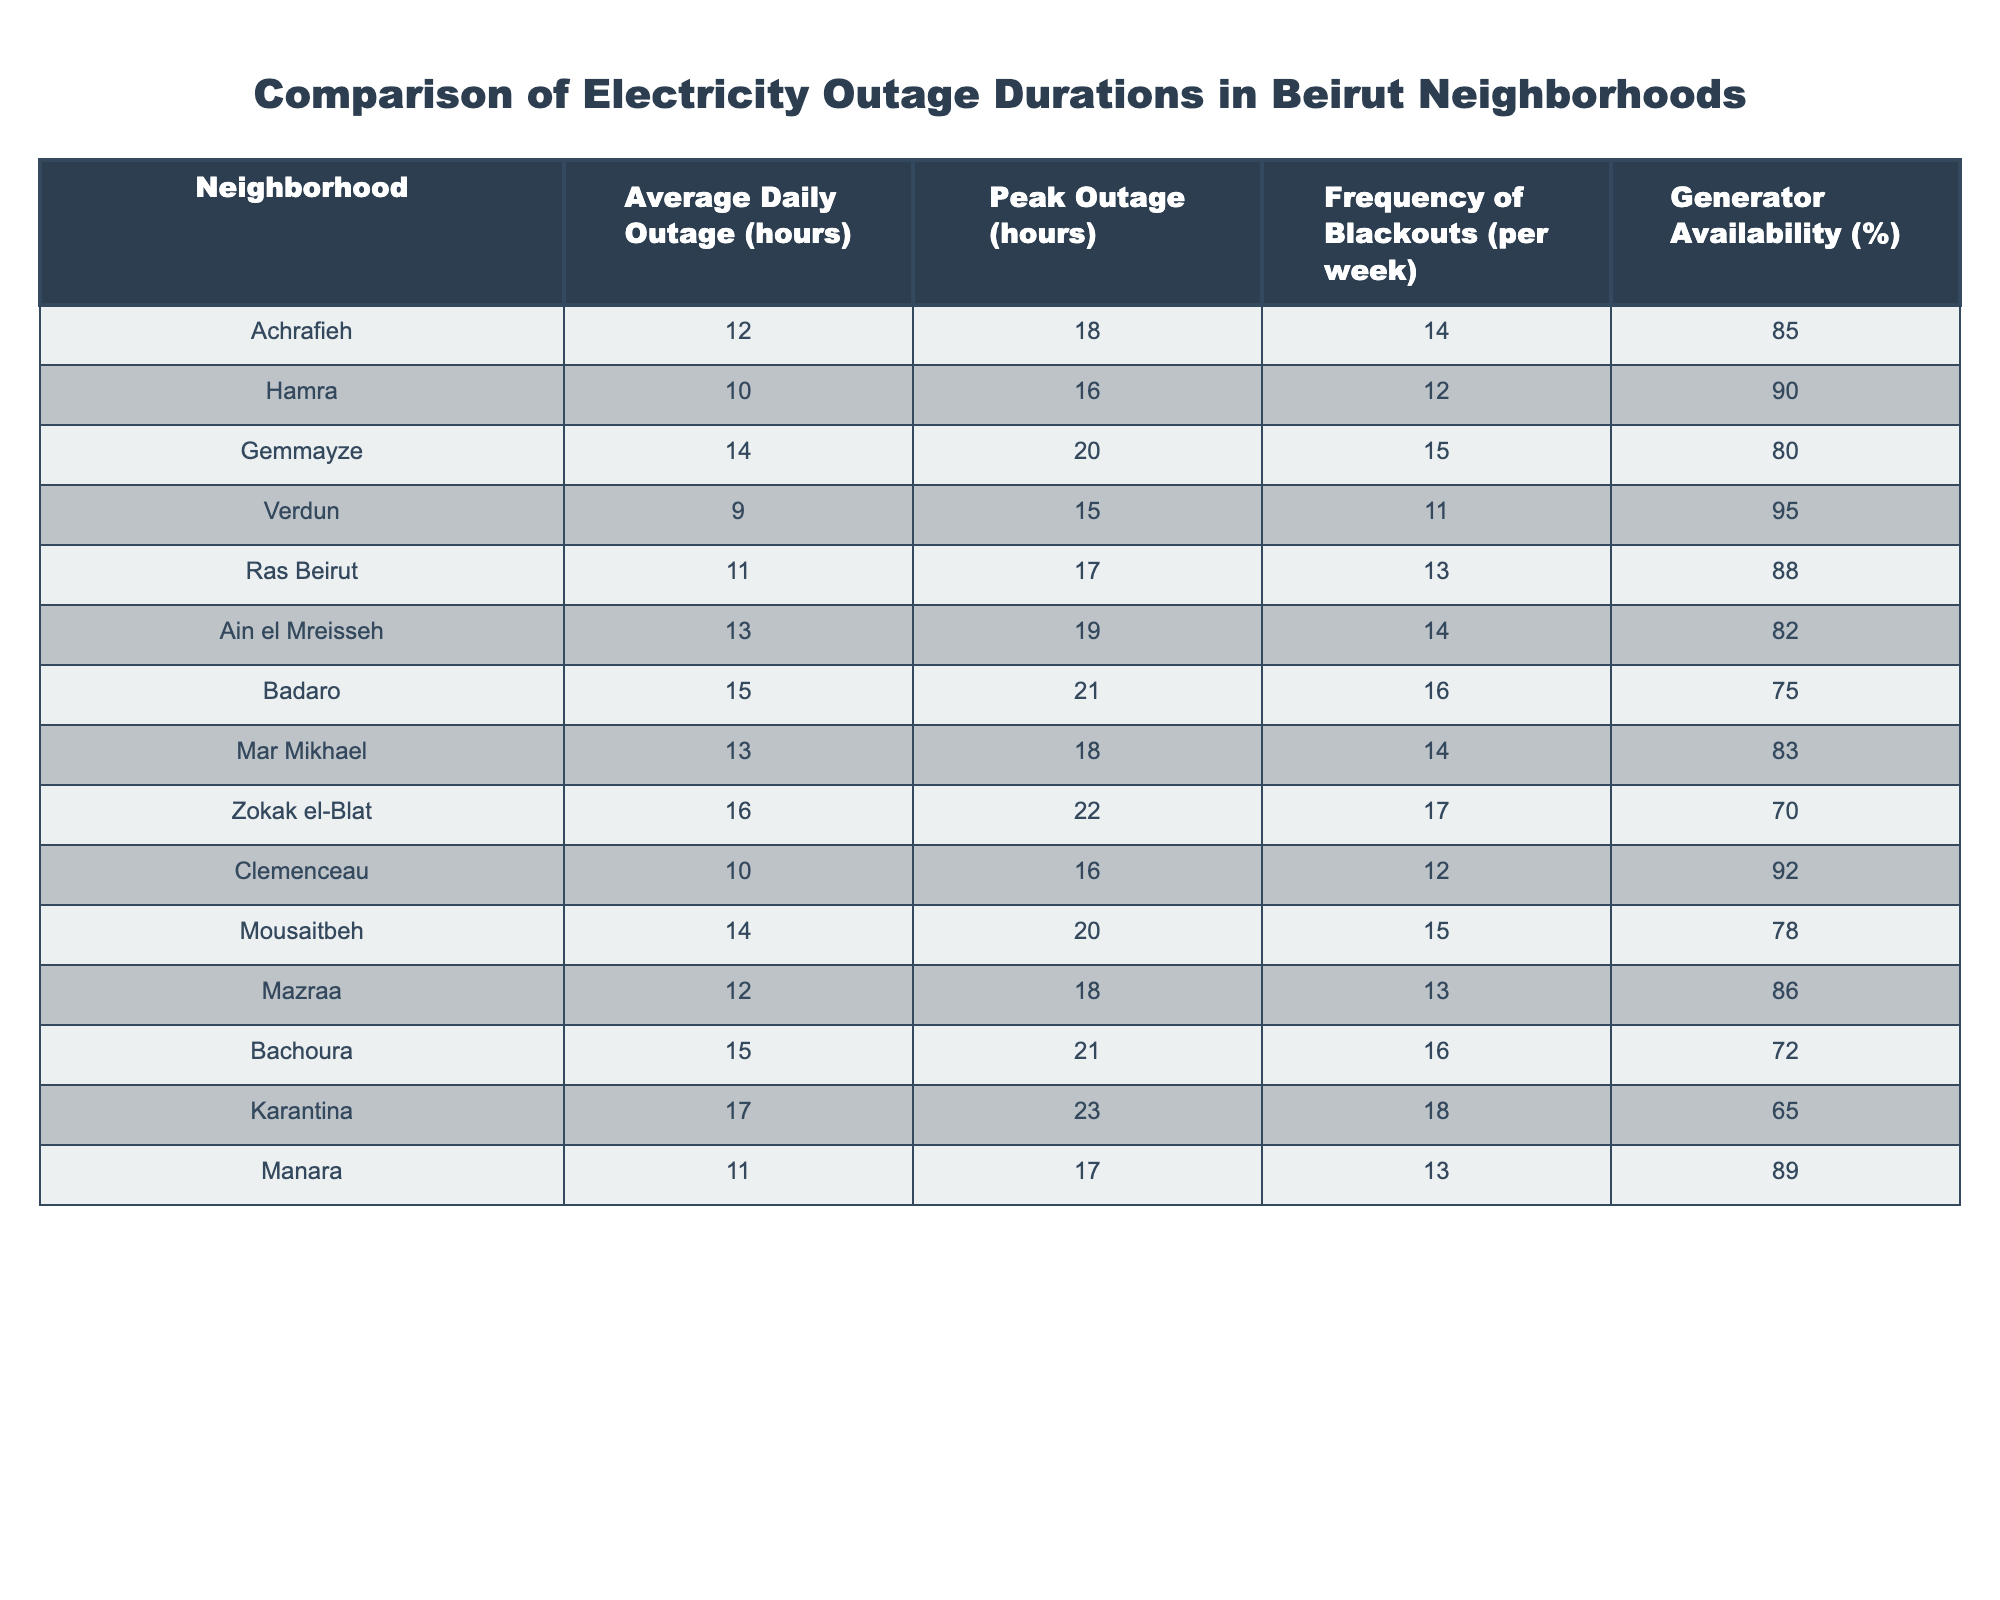What is the average daily outage duration in the Achrafieh neighborhood? The table indicates the average daily outage for Achrafieh is listed under "Average Daily Outage (hours)". Referring to the table, it shows a value of 12 hours.
Answer: 12 hours Which neighborhood has the highest peak outage duration? By comparing the "Peak Outage (hours)" column, we find that Zokak el-Blat has the highest peak outage duration with a value of 22 hours.
Answer: Zokak el-Blat How many neighborhoods have an average daily outage greater than 12 hours? Analyzing the "Average Daily Outage (hours)" column, we identify the neighborhoods with values greater than 12 hours: Gemmayze (14), Ain el Mreisseh (13), Badaro (15), Mousaitbeh (14), Zokak el-Blat (16), and Karantina (17). This totals to 6 neighborhoods.
Answer: 6 neighborhoods Is the frequency of blackouts in Hamra higher than in Verdun? The table shows that Hamra has a frequency of 12 blackouts per week, while Verdun has 11 blackouts per week. Thus, Hamra’s frequency is indeed higher than Verdun's.
Answer: Yes What is the difference in generator availability between Zokak el-Blat and Achrafieh? For Zokak el-Blat, the generator availability is 70%, while for Achrafieh, it is 85%. The difference is 85% - 70% = 15%.
Answer: 15% Which neighborhood has both the highest frequency of blackouts and average daily outage duration? Looking at the "Frequency of Blackouts (per week)" and "Average Daily Outage (hours)" columns, Badaro has the highest frequency (16) and an average daily outage of 15 hours among all neighborhoods.
Answer: Badaro Is the average daily outage in Ras Beirut less than 12 hours? The table displays the average daily outage in Ras Beirut as 11 hours. Since 11 hours is less than 12 hours, the answer is yes.
Answer: Yes What is the average peak outage duration across all neighborhoods? To calculate the average peak outage, sum the values from the "Peak Outage (hours)" column: 18 + 16 + 20 + 15 + 17 + 19 + 21 + 18 + 22 + 16 + 20 + 18 + 21 + 23 + 17 = 290. Since there are 15 neighborhoods, divide the total by 15, resulting in an average of 19.33 hours.
Answer: 19.33 hours 